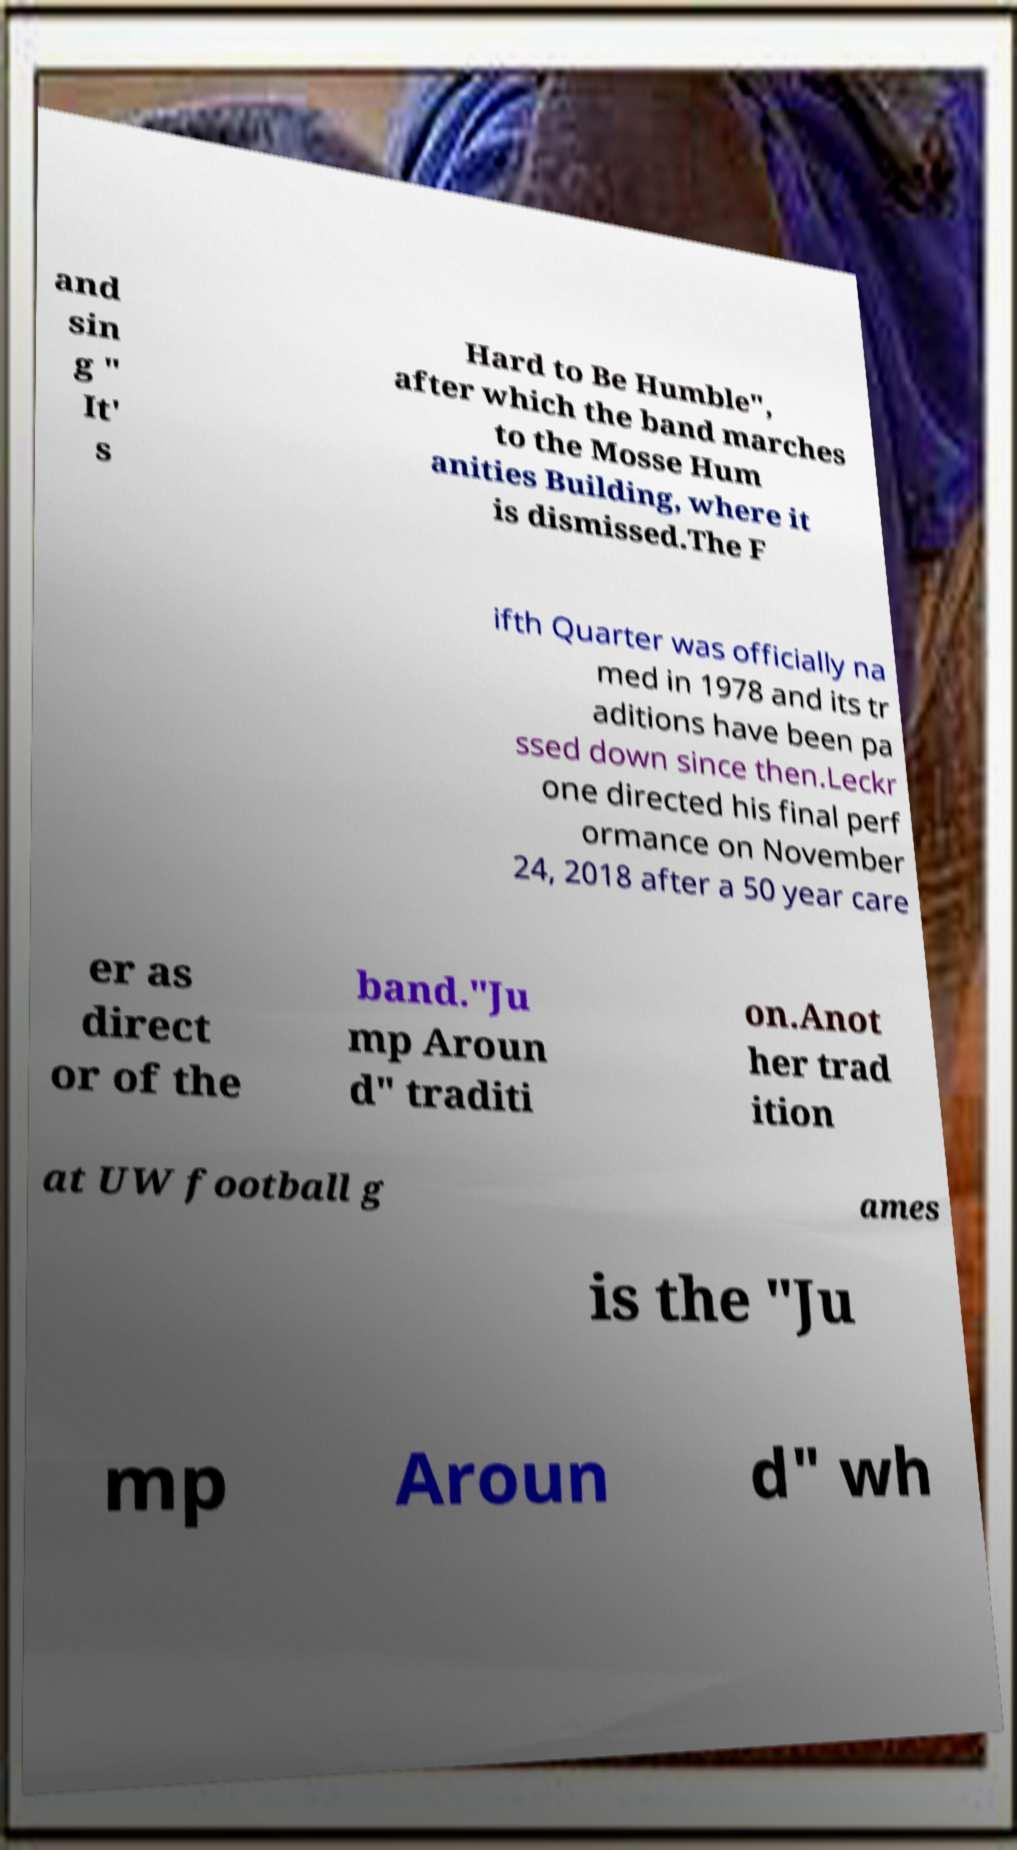I need the written content from this picture converted into text. Can you do that? and sin g " It' s Hard to Be Humble", after which the band marches to the Mosse Hum anities Building, where it is dismissed.The F ifth Quarter was officially na med in 1978 and its tr aditions have been pa ssed down since then.Leckr one directed his final perf ormance on November 24, 2018 after a 50 year care er as direct or of the band."Ju mp Aroun d" traditi on.Anot her trad ition at UW football g ames is the "Ju mp Aroun d" wh 